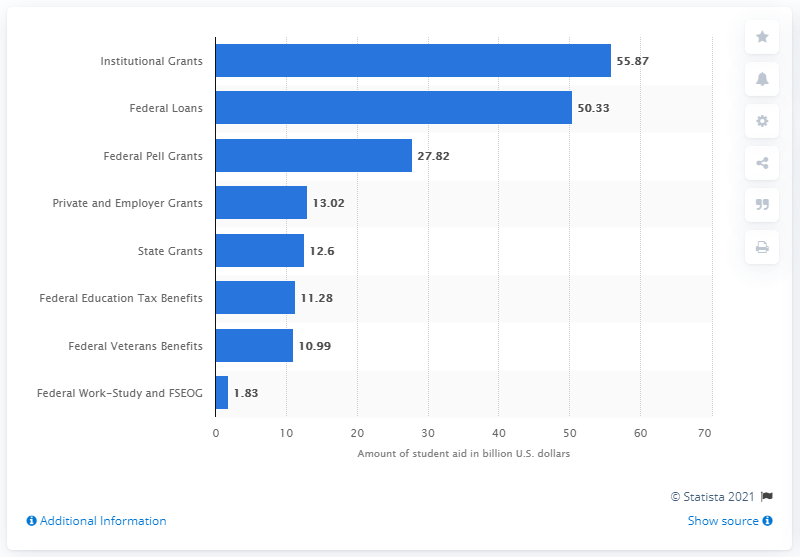Indicate a few pertinent items in this graphic. A total of $27.82 million was provided to students in the form of Federal Pell Grants. 